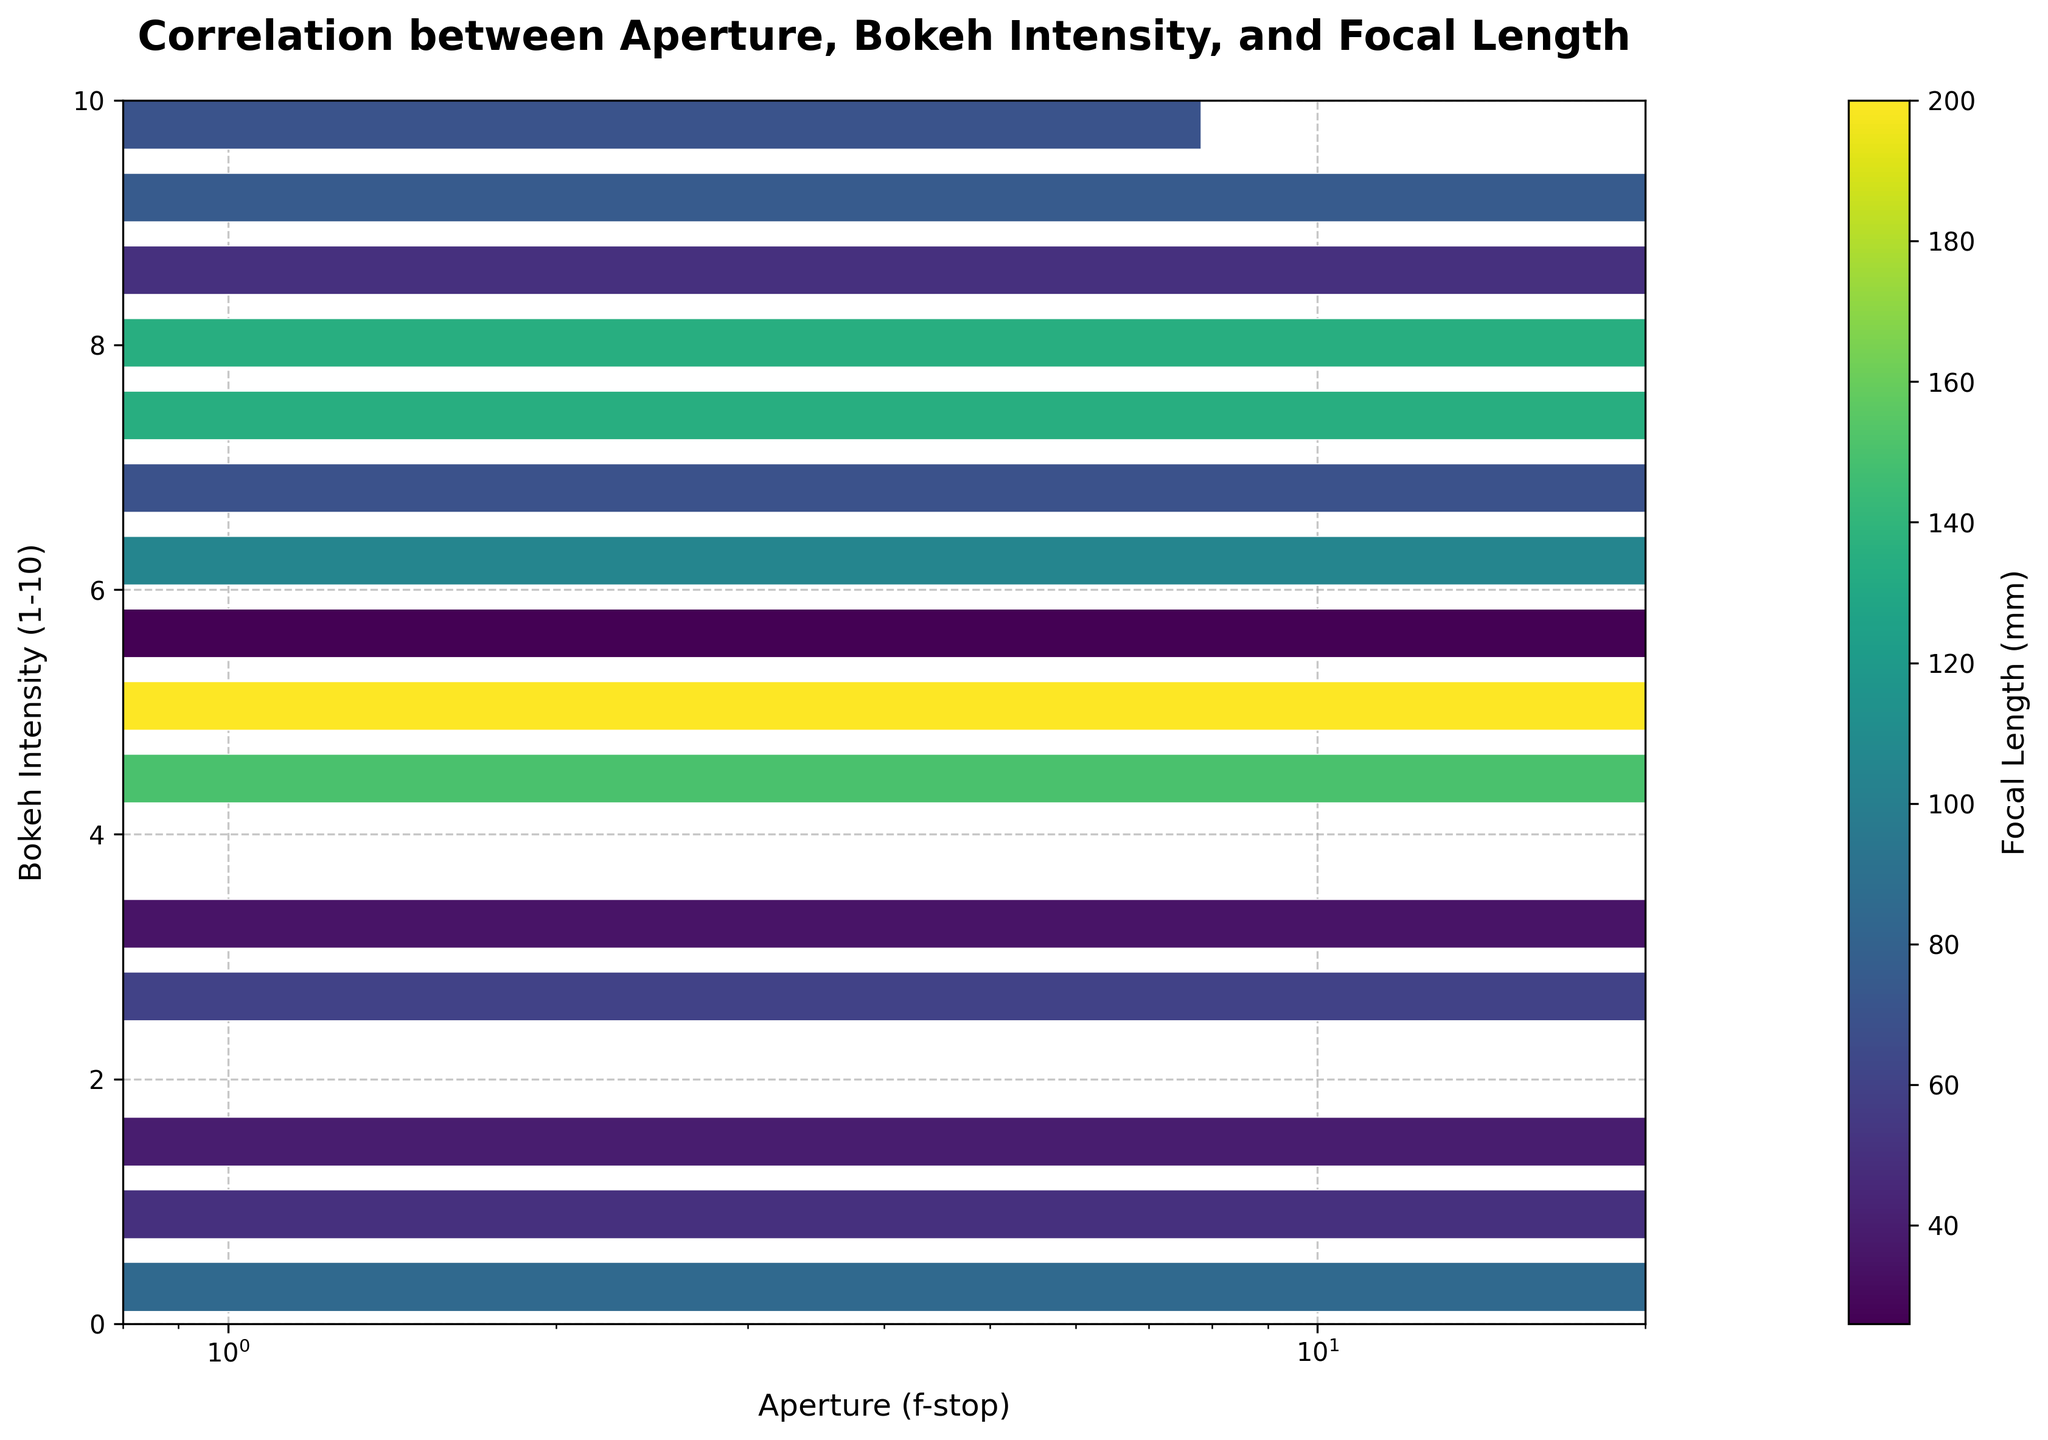What's the title of the figure? The title is displayed prominently at the top of the figure. It reads "Correlation between Aperture, Bokeh Intensity, and Focal Length."
Answer: Correlation between Aperture, Bokeh Intensity, and Focal Length What is shown on the x-axis and y-axis? The x-axis represents "Aperture (f-stop)" and the y-axis represents "Bokeh Intensity (1-10)." This information is visible from the axis labels.
Answer: Aperture (f-stop) on x-axis and Bokeh Intensity (1-10) on y-axis What is the color gradient representing in the plot? The color gradient represents the "Focal Length (mm)" as indicated by the color bar on the right side of the figure. Different shades indicate different values of focal length.
Answer: Focal Length (mm) At which aperture setting does the plot show the highest Bokeh intensity? By observing where the darkest points (highest values of Bokeh Intensity) concentrate along the x-axis, we can see that the highest Bokeh Intensity occurs around the aperture setting of f/1.2 to f/1.4.
Answer: f/1.2 to f/1.4 How does Bokeh Intensity change as the aperture setting increases? By following the pattern of hexagons from the left to the right of the x-axis, it is noticeable that Bokeh Intensity decreases as the aperture setting increases. This can be observed from the lightening of the hexagon colors as you move right.
Answer: It decreases Which focal length is most frequently associated with high Bokeh Intensity values? High Bokeh Intensity values occur in the darker areas of the plot. The color gradient indicates that these areas are colored in shades that correspond approximately to focal lengths around 50mm to 90mm.
Answer: 50mm to 90mm Is there a noticeable pattern between focal length and Bokeh Intensity? Observing the color distribution in the plot, it is evident that longer focal lengths are generally associated with lower Bokeh Intensities, as signals with higher focal lengths (lighter colors) cluster in the lower part of the Bokeh Intensity scale.
Answer: Longer focal lengths generally have lower Bokeh Intensities At an aperture setting of around f/2.8, what range of Bokeh Intensity is observed? By focusing on the vertical column corresponding to f/2.8 on the x-axis, we see Bokeh Intensities that range roughly between 7 and 8.
Answer: Between 7 and 8 Which aperture settings show a Bokeh Intensity above 8? By examining hexagons with values above 8 on the Bokeh Intensity scale, we find that these occur at aperture settings around f/1.2, f/1.4, and f/1.6.
Answer: f/1.2, f/1.4, f/1.6 